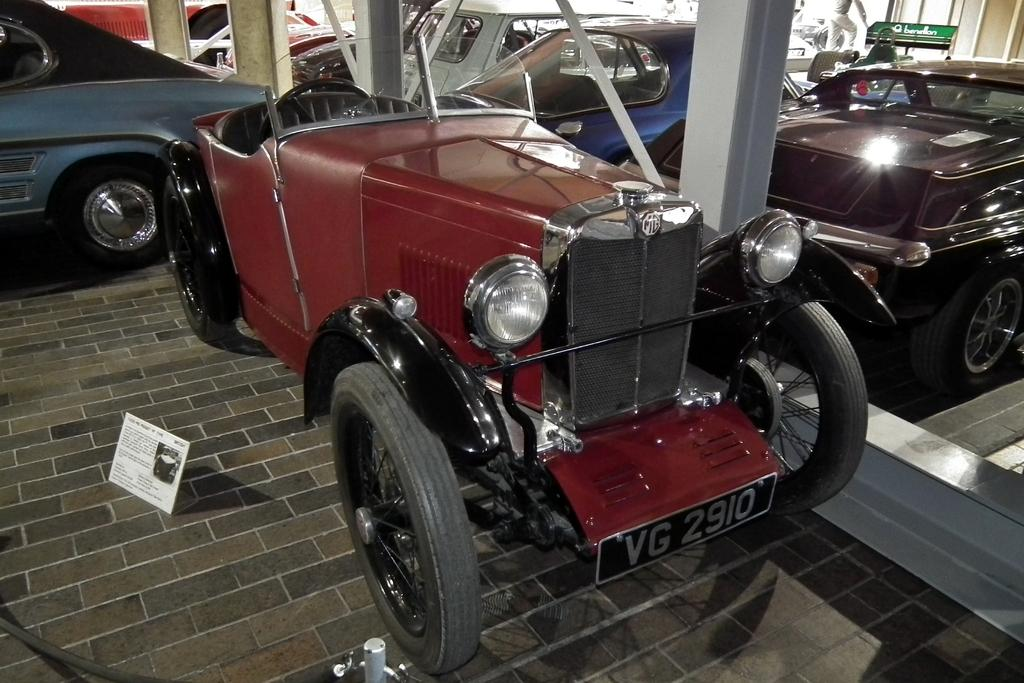<image>
Give a short and clear explanation of the subsequent image. A very old red car with the word Benetton visible in the background 